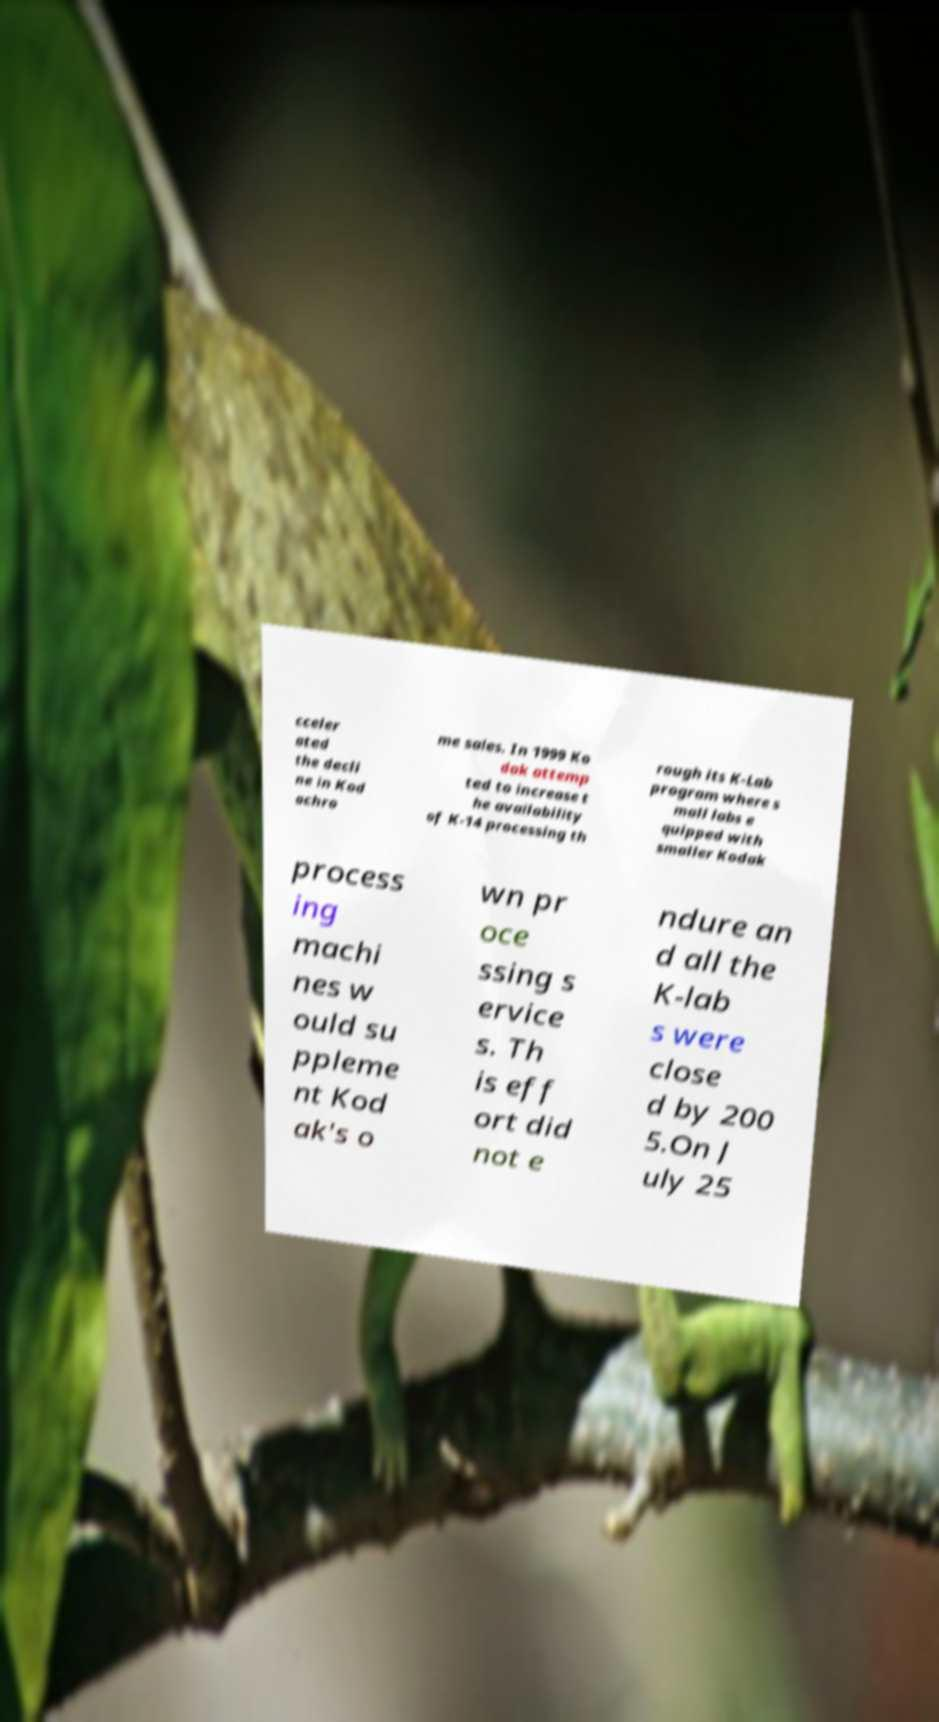For documentation purposes, I need the text within this image transcribed. Could you provide that? cceler ated the decli ne in Kod achro me sales. In 1999 Ko dak attemp ted to increase t he availability of K-14 processing th rough its K-Lab program where s mall labs e quipped with smaller Kodak process ing machi nes w ould su ppleme nt Kod ak's o wn pr oce ssing s ervice s. Th is eff ort did not e ndure an d all the K-lab s were close d by 200 5.On J uly 25 